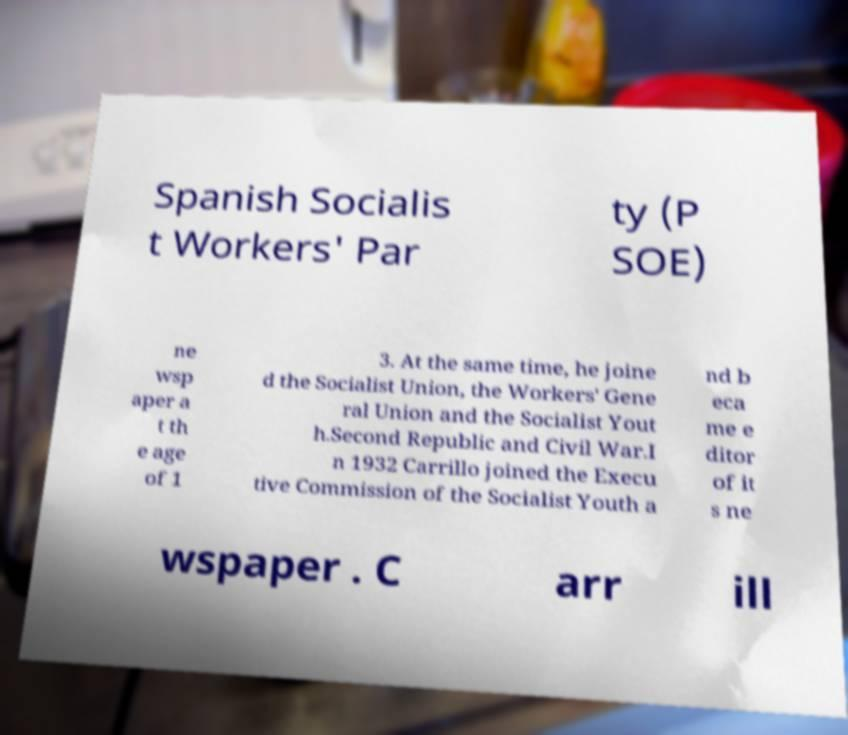Could you assist in decoding the text presented in this image and type it out clearly? Spanish Socialis t Workers' Par ty (P SOE) ne wsp aper a t th e age of 1 3. At the same time, he joine d the Socialist Union, the Workers' Gene ral Union and the Socialist Yout h.Second Republic and Civil War.I n 1932 Carrillo joined the Execu tive Commission of the Socialist Youth a nd b eca me e ditor of it s ne wspaper . C arr ill 